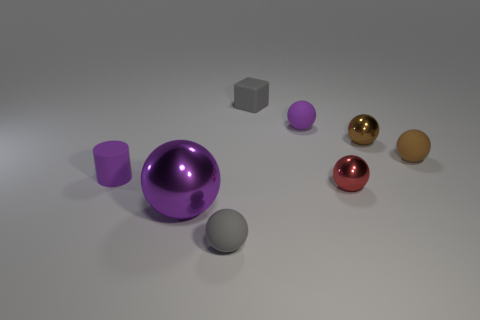Add 2 blocks. How many objects exist? 10 Subtract all gray spheres. Subtract all green blocks. How many spheres are left? 5 Subtract all yellow spheres. How many yellow cylinders are left? 0 Subtract all tiny matte cylinders. Subtract all purple rubber objects. How many objects are left? 5 Add 5 small red spheres. How many small red spheres are left? 6 Add 5 tiny red metal spheres. How many tiny red metal spheres exist? 6 Subtract all gray spheres. How many spheres are left? 5 Subtract all small gray rubber balls. How many balls are left? 5 Subtract 1 purple cylinders. How many objects are left? 7 Subtract all cylinders. How many objects are left? 7 